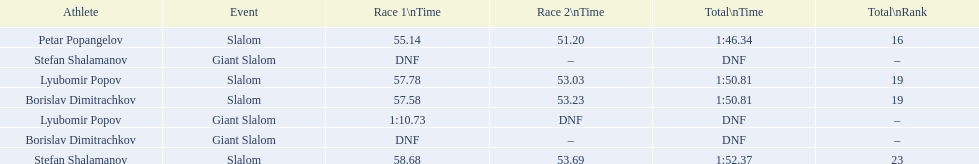What are all the competitions lyubomir popov competed in? Lyubomir Popov, Lyubomir Popov. Of those, which were giant slalom races? Giant Slalom. What was his time in race 1? 1:10.73. 